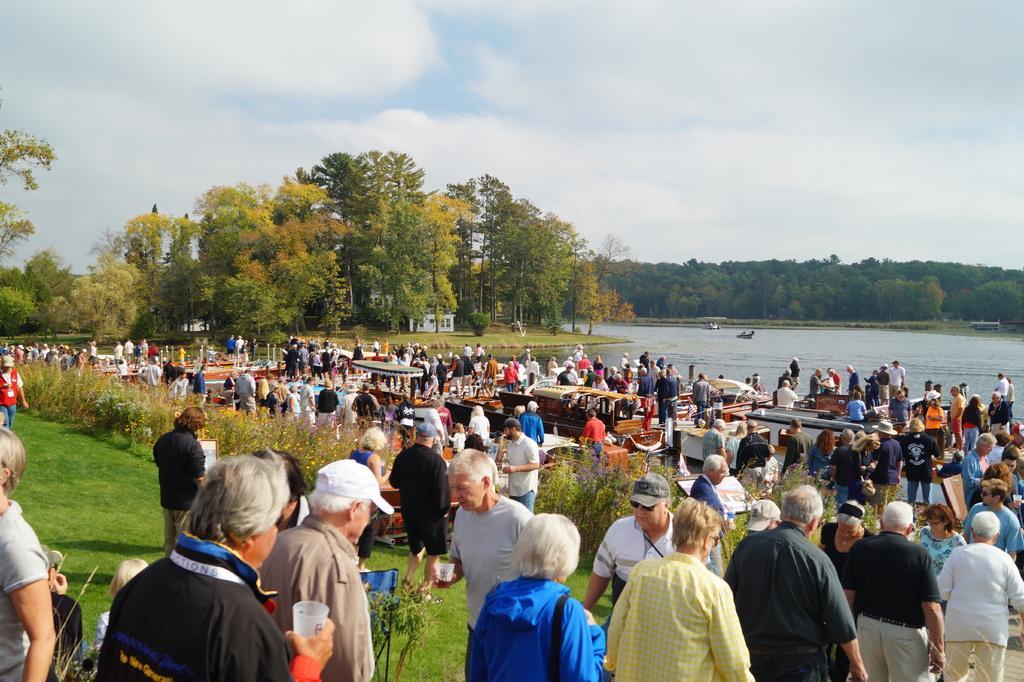Please provide a concise description of this image. In this image we can see people, boats, water, grass, plants, boards, houses, trees, and few objects. In the background there is sky with clouds. 